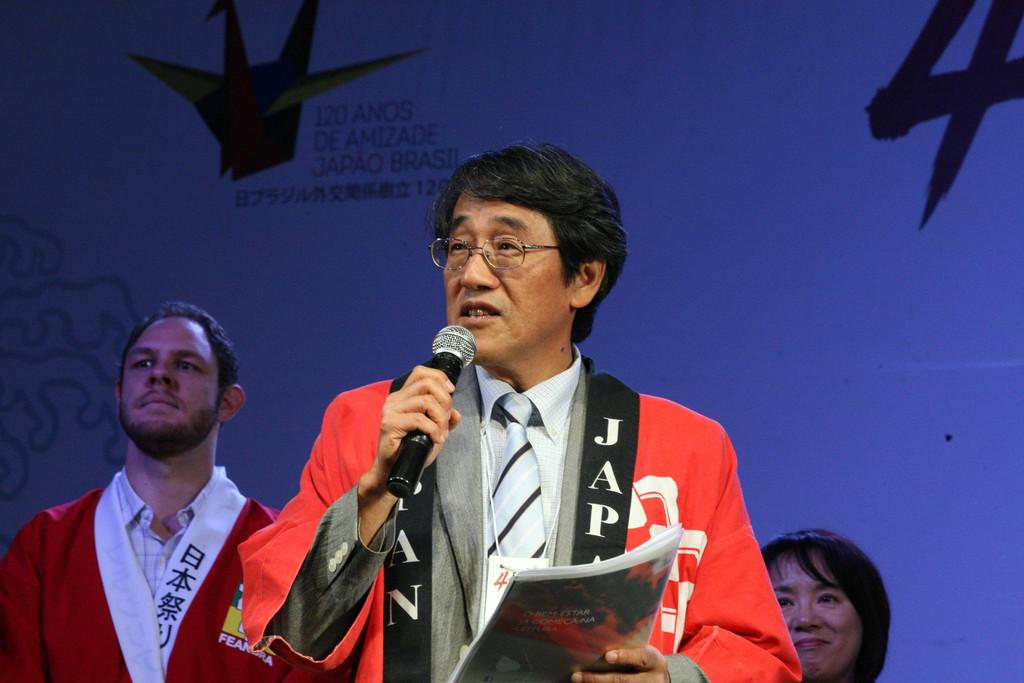<image>
Relay a brief, clear account of the picture shown. A man wearing a coat with JAP down the front speaks into a microphone. 